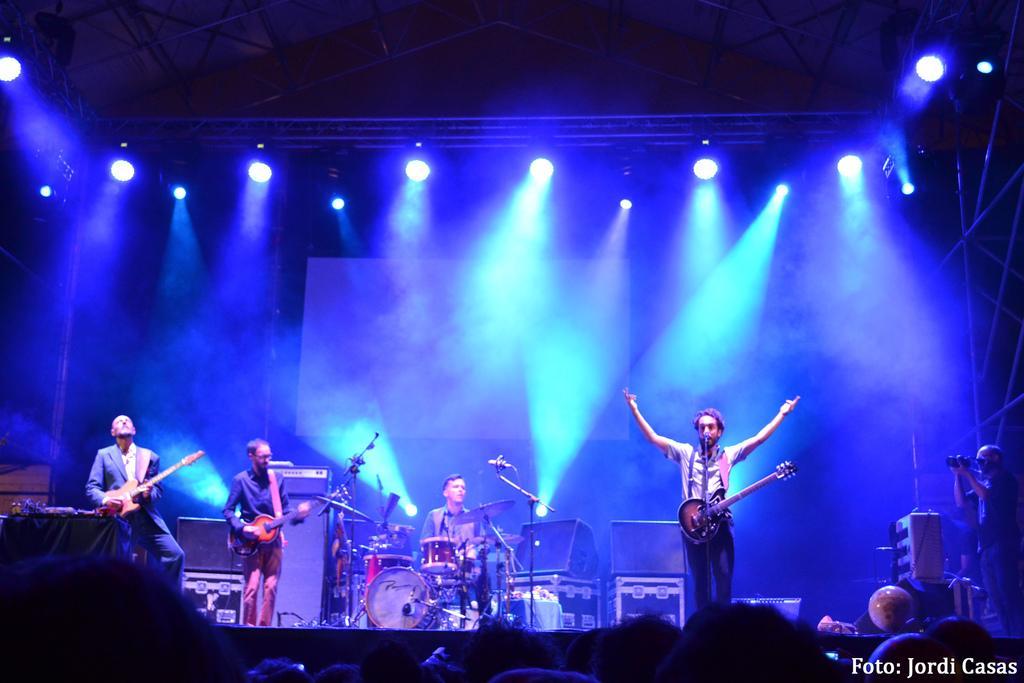In one or two sentences, can you explain what this image depicts? In this image I can see number of people where three of them are holding guitars and one is sitting next to a drum set. In the background I can see few lights and here I can see few mics. 